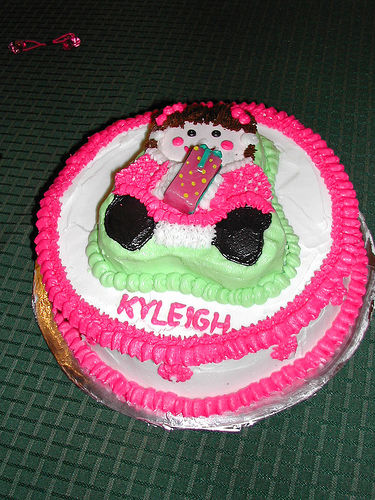<image>
Is there a cake on the table? Yes. Looking at the image, I can see the cake is positioned on top of the table, with the table providing support. 